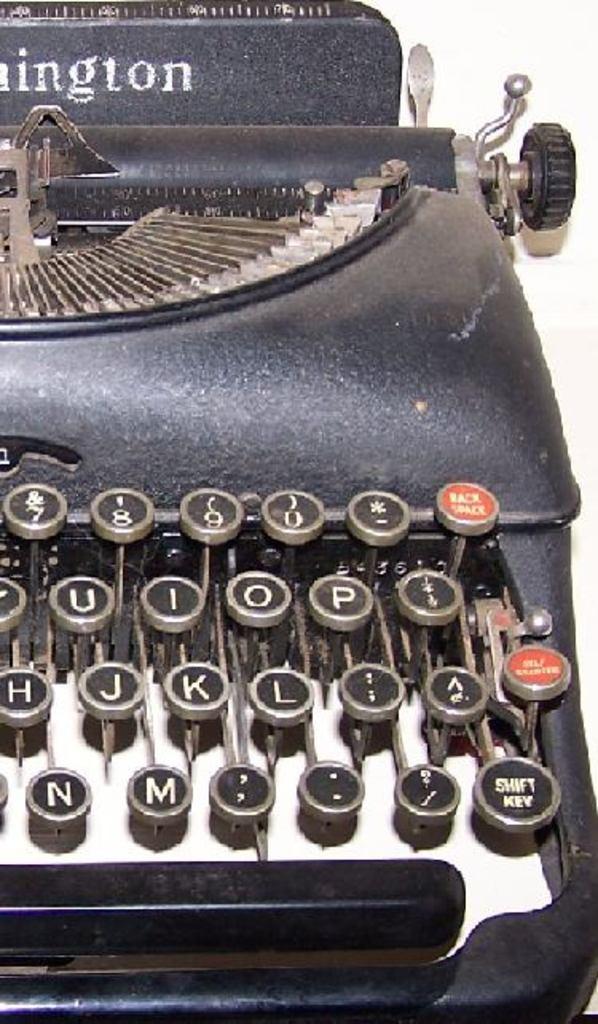Could you give a brief overview of what you see in this image? In this image I can see a typewriter which is in black color. Here I can see the letters on the buttons. At the top of this typewriter there is some text. The background is in white color. 